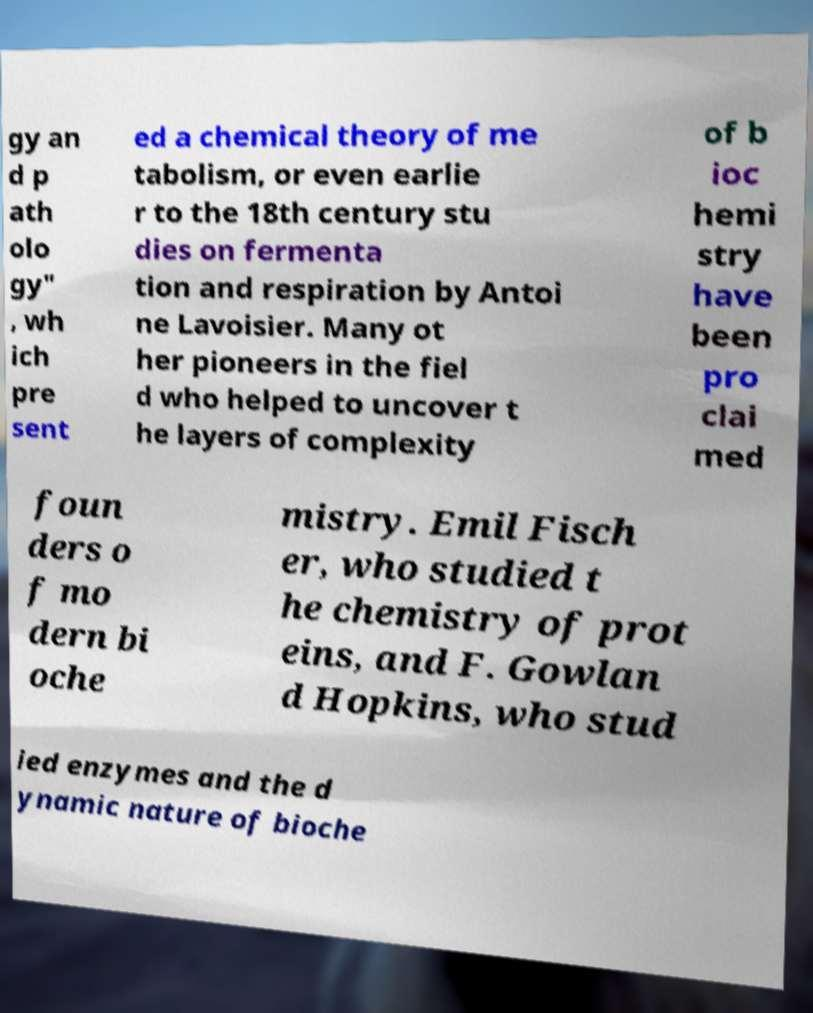For documentation purposes, I need the text within this image transcribed. Could you provide that? gy an d p ath olo gy" , wh ich pre sent ed a chemical theory of me tabolism, or even earlie r to the 18th century stu dies on fermenta tion and respiration by Antoi ne Lavoisier. Many ot her pioneers in the fiel d who helped to uncover t he layers of complexity of b ioc hemi stry have been pro clai med foun ders o f mo dern bi oche mistry. Emil Fisch er, who studied t he chemistry of prot eins, and F. Gowlan d Hopkins, who stud ied enzymes and the d ynamic nature of bioche 